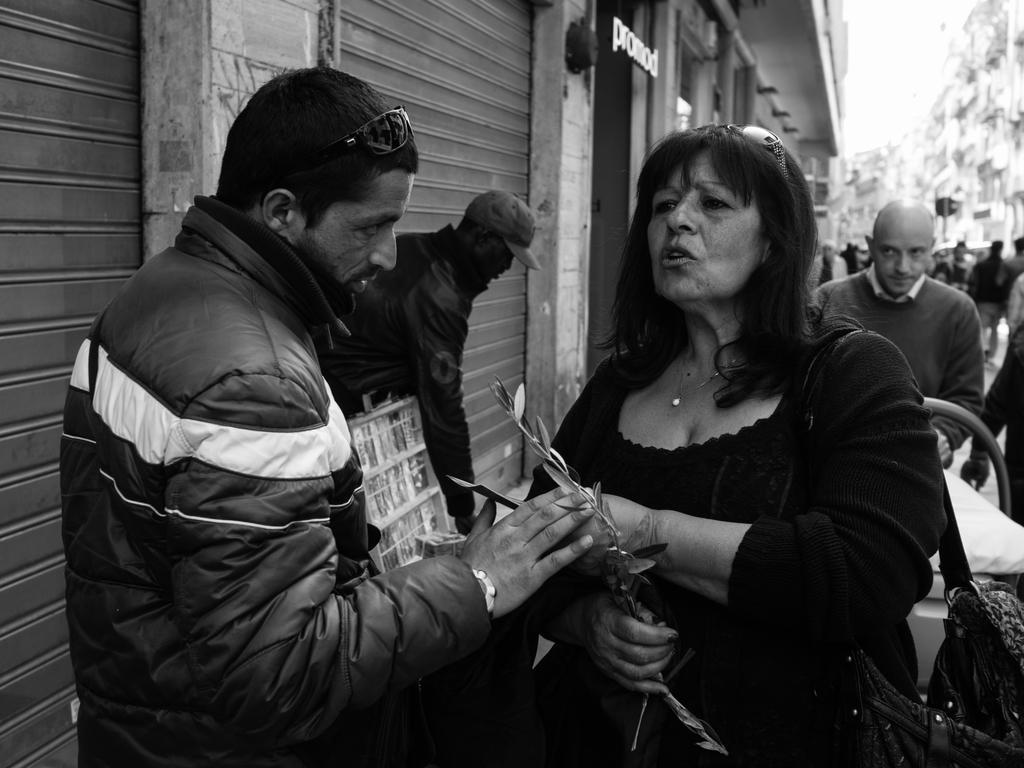Can you describe this image briefly? In a given image I can see a rolling shutters, people and buildings. 